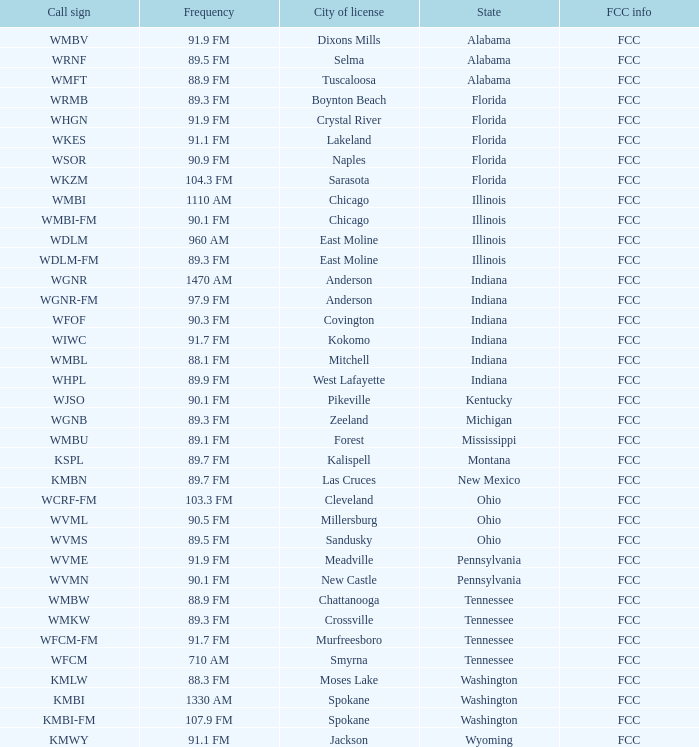1 fm frequency and a city license in new castle? Pennsylvania. 